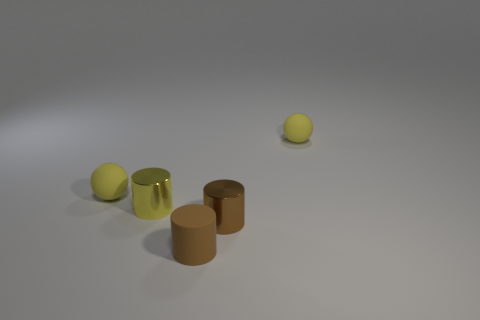Are there any small cubes made of the same material as the yellow cylinder?
Offer a terse response. No. What is the shape of the brown rubber thing?
Your answer should be very brief. Cylinder. Do the yellow cylinder and the brown metallic object have the same size?
Offer a terse response. Yes. What number of other things are the same shape as the yellow metallic thing?
Keep it short and to the point. 2. The shiny object to the left of the rubber cylinder has what shape?
Ensure brevity in your answer.  Cylinder. There is a tiny yellow metallic object that is to the left of the small brown rubber thing; does it have the same shape as the tiny object that is in front of the brown metal cylinder?
Keep it short and to the point. Yes. Are there the same number of tiny brown cylinders that are in front of the brown metallic thing and tiny yellow metal things?
Offer a very short reply. Yes. Are there any other things that have the same size as the brown metallic cylinder?
Keep it short and to the point. Yes. There is a small yellow object that is the same shape as the brown rubber thing; what is its material?
Ensure brevity in your answer.  Metal. The brown matte thing that is to the left of the tiny matte sphere on the right side of the yellow metallic object is what shape?
Ensure brevity in your answer.  Cylinder. 